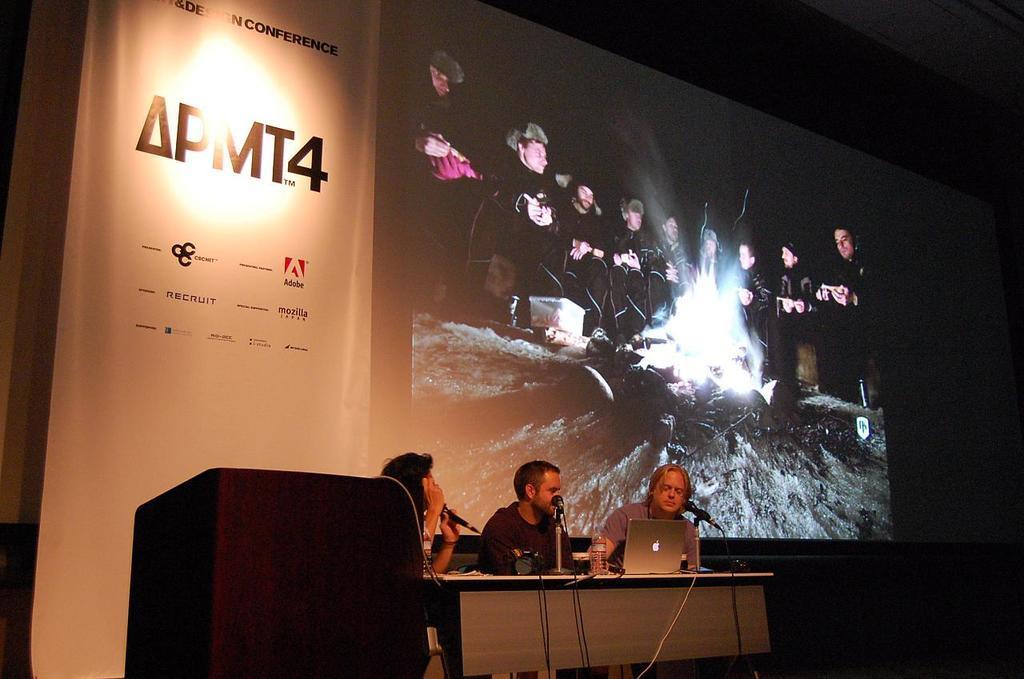Can you describe this image briefly? In the image I can see three people who are sitting in front of the table on which there is a laptop, and to the side there is a desk and behind there is a projector screen. 